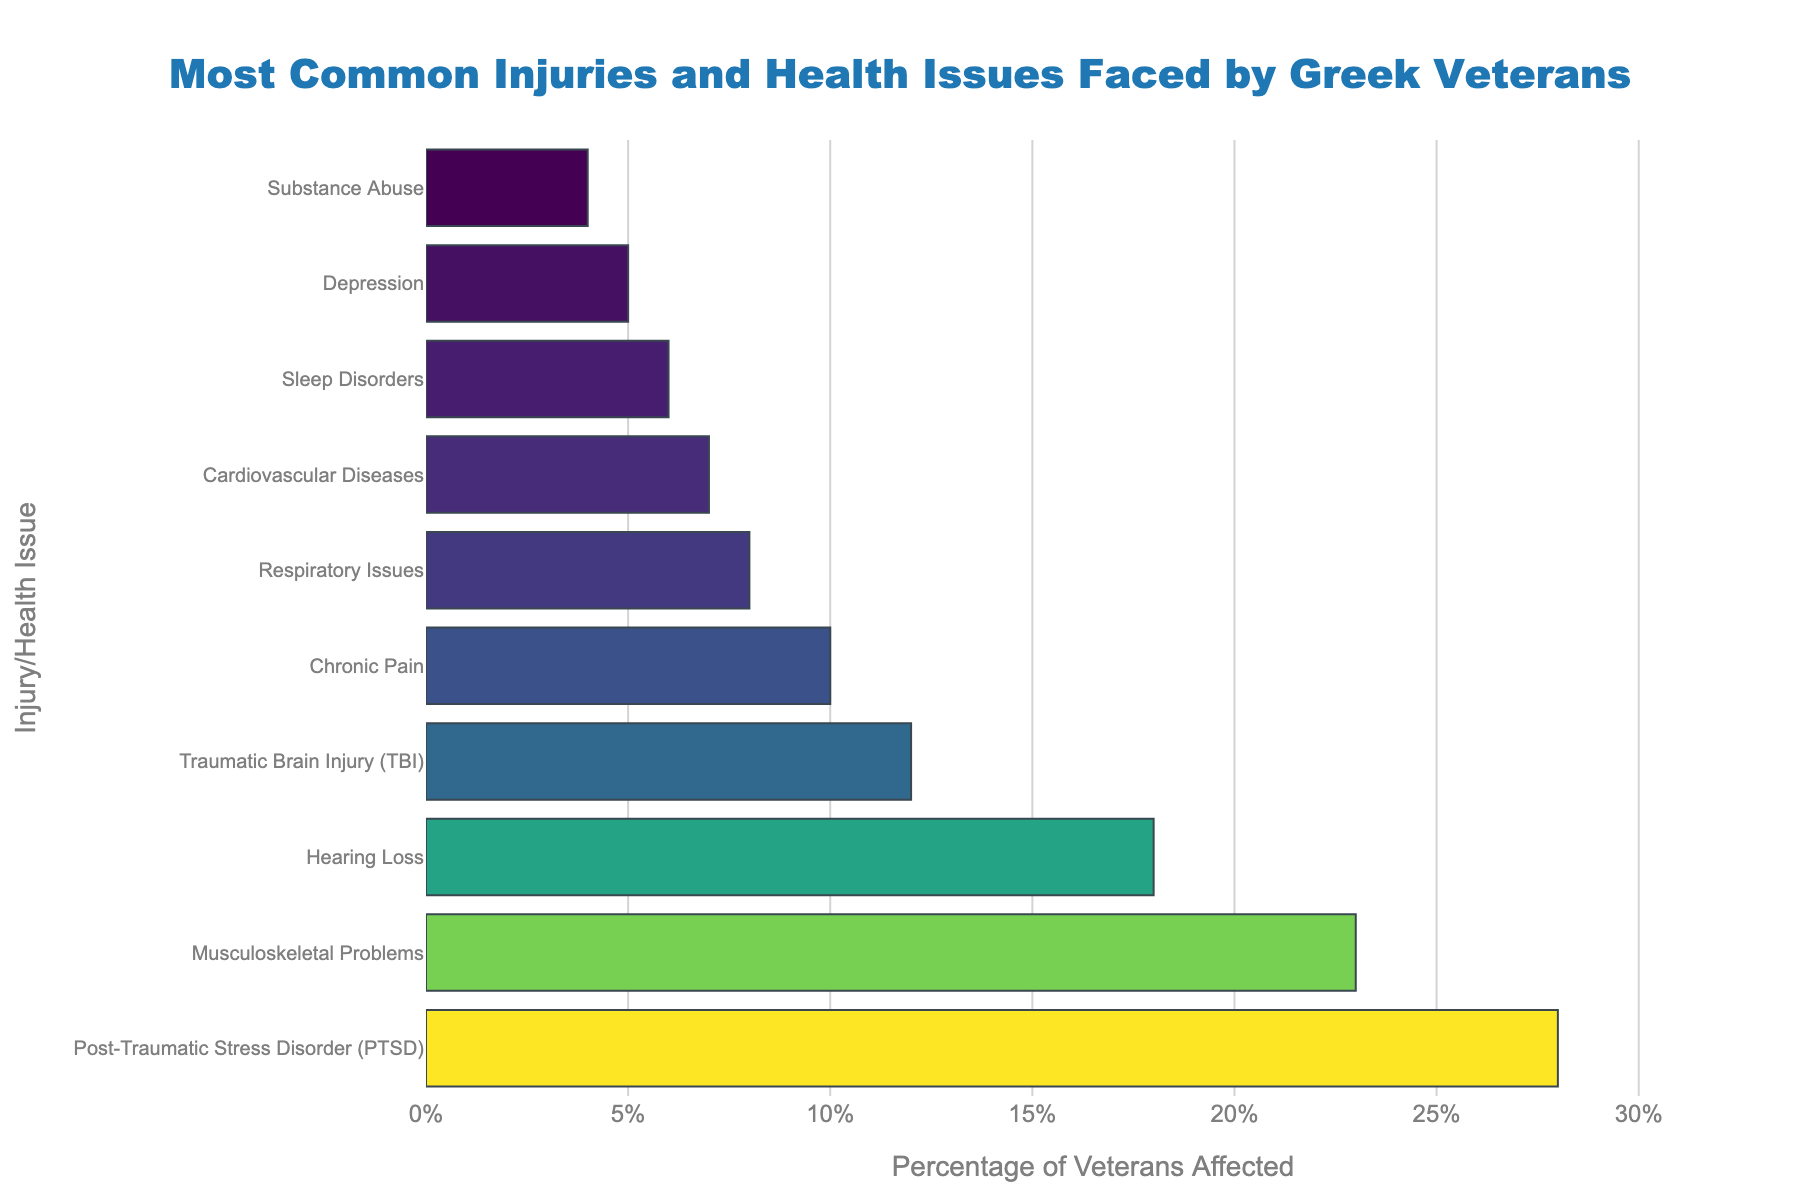Which injury or health issue affects the largest percentage of Greek veterans? The largest bar on the chart corresponds to Post-Traumatic Stress Disorder (PTSD), indicating it affects the largest percentage.
Answer: Post-Traumatic Stress Disorder (PTSD) Which health issue affects a higher percentage of veterans: Musculoskeletal Problems or Chronic Pain? By comparing the height of the bars, Musculoskeletal Problems (23%) is higher than Chronic Pain (10%).
Answer: Musculoskeletal Problems What is the combined percentage of veterans affected by Hearing Loss and Traumatic Brain Injury (TBI)? Adding the percentages, Hearing Loss (18%) and TBI (12%) gives 18 + 12 = 30%.
Answer: 30% Is the percentage of veterans affected by Sleep Disorders higher or lower than those affected by Cardiovascular Diseases? The bar for Sleep Disorders (6%) is shorter than the one for Cardiovascular Diseases (7%).
Answer: Lower What is the third most common health issue faced by Greek veterans according to the chart? The third highest bar corresponds to Hearing Loss, which is 18%.
Answer: Hearing Loss How much more common is Musculoskeletal Problems compared to Sleep Disorders? Subtracting the percentages, 23% (Musculoskeletal Problems) - 6% (Sleep Disorders) = 17%.
Answer: 17% What is the least common health issue among Greek veterans? The shortest bar represents Substance Abuse at 4%.
Answer: Substance Abuse What is the total percentage of veterans affected by injuries and health issues listed in the chart? Adding all percentages: 28% + 23% + 18% + 12% + 10% + 8% + 7% + 6% + 5% + 4% = 121%.
Answer: 121% How does the percentage of veterans affected by Chronic Pain compare to those affected by Respiratory Issues? The bar for Chronic Pain (10%) is taller than the bar for Respiratory Issues (8%).
Answer: Higher What is the average percentage of veterans affected by Cardiovascular Diseases and Depression? Calculating the average: (7% + 5%) / 2 = 6%.
Answer: 6% 